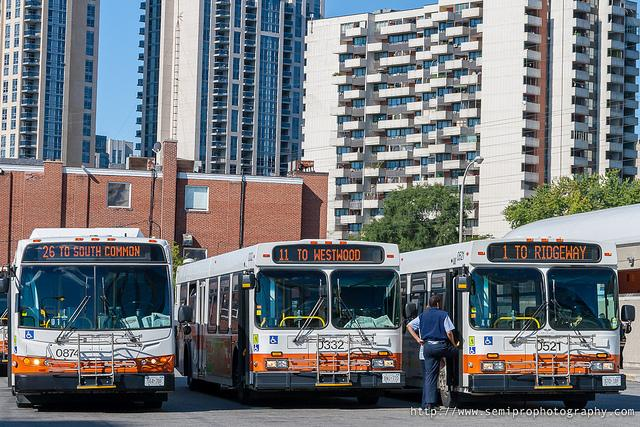The man standing near the buses is probably there to do what? drive 